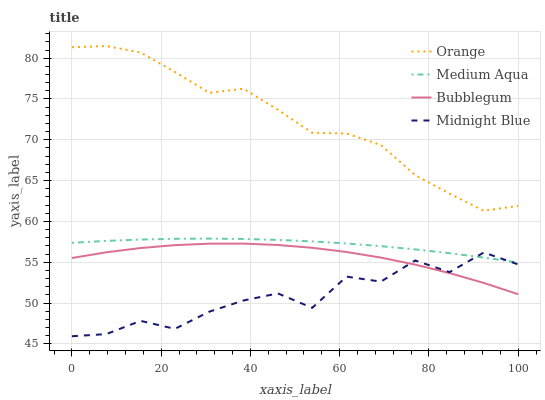Does Midnight Blue have the minimum area under the curve?
Answer yes or no. Yes. Does Orange have the maximum area under the curve?
Answer yes or no. Yes. Does Medium Aqua have the minimum area under the curve?
Answer yes or no. No. Does Medium Aqua have the maximum area under the curve?
Answer yes or no. No. Is Medium Aqua the smoothest?
Answer yes or no. Yes. Is Midnight Blue the roughest?
Answer yes or no. Yes. Is Midnight Blue the smoothest?
Answer yes or no. No. Is Medium Aqua the roughest?
Answer yes or no. No. Does Medium Aqua have the lowest value?
Answer yes or no. No. Does Medium Aqua have the highest value?
Answer yes or no. No. Is Bubblegum less than Medium Aqua?
Answer yes or no. Yes. Is Orange greater than Medium Aqua?
Answer yes or no. Yes. Does Bubblegum intersect Medium Aqua?
Answer yes or no. No. 